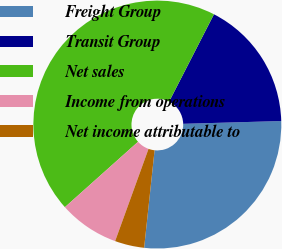<chart> <loc_0><loc_0><loc_500><loc_500><pie_chart><fcel>Freight Group<fcel>Transit Group<fcel>Net sales<fcel>Income from operations<fcel>Net income attributable to<nl><fcel>27.15%<fcel>17.0%<fcel>44.16%<fcel>7.86%<fcel>3.83%<nl></chart> 